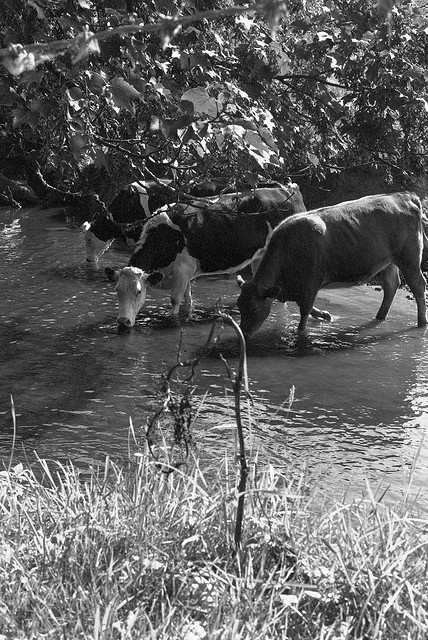Describe the objects in this image and their specific colors. I can see cow in black, gray, darkgray, and lightgray tones, cow in black, gray, and lightgray tones, and cow in black, gray, darkgray, and lightgray tones in this image. 